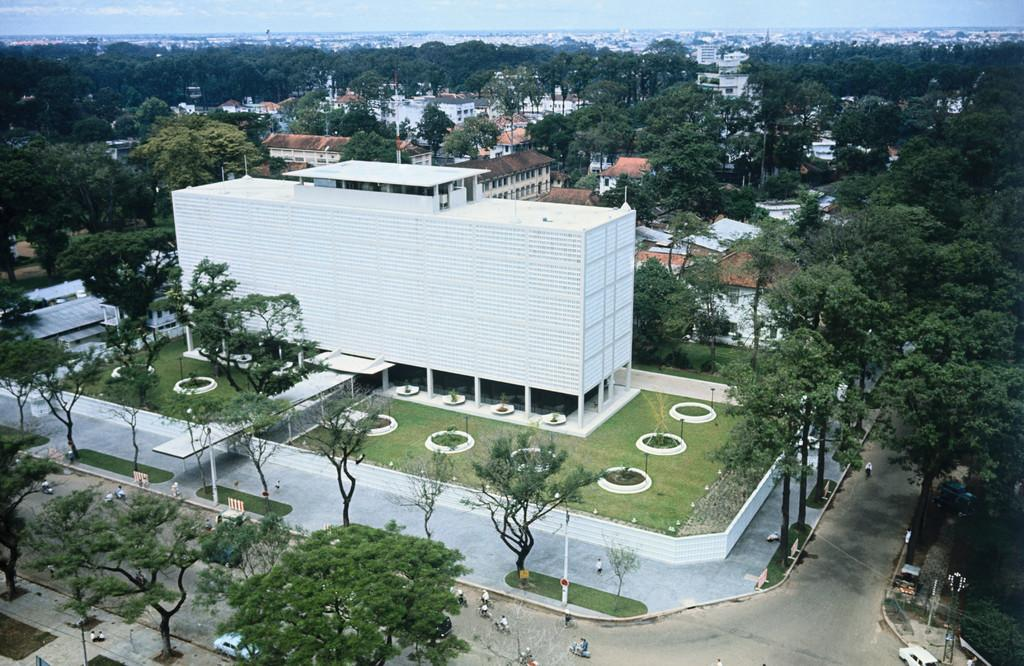What type of man-made structures can be seen in the image? There are buildings in the image. What natural elements are present in the image? There are trees and grass on the ground in the image. What type of terrain is visible in the image? The image shows roads, trees, and grass, which suggests a combination of urban and natural landscapes. What can be seen in the background of the image? There are trees in the background of the image. What type of butter is being used to grease the roads in the image? There is no butter present in the image, and the roads do not appear to be greased. How does the cabbage in the image compare to the trees in terms of height? There is no cabbage present in the image, so it cannot be compared to the trees. 